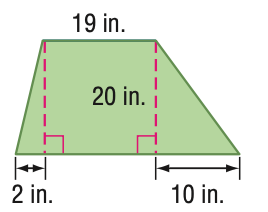Answer the mathemtical geometry problem and directly provide the correct option letter.
Question: Find the area of the figure. Round to the nearest tenth if necessary.
Choices: A: 92.5 B: 250 C: 500 D: 1000 C 